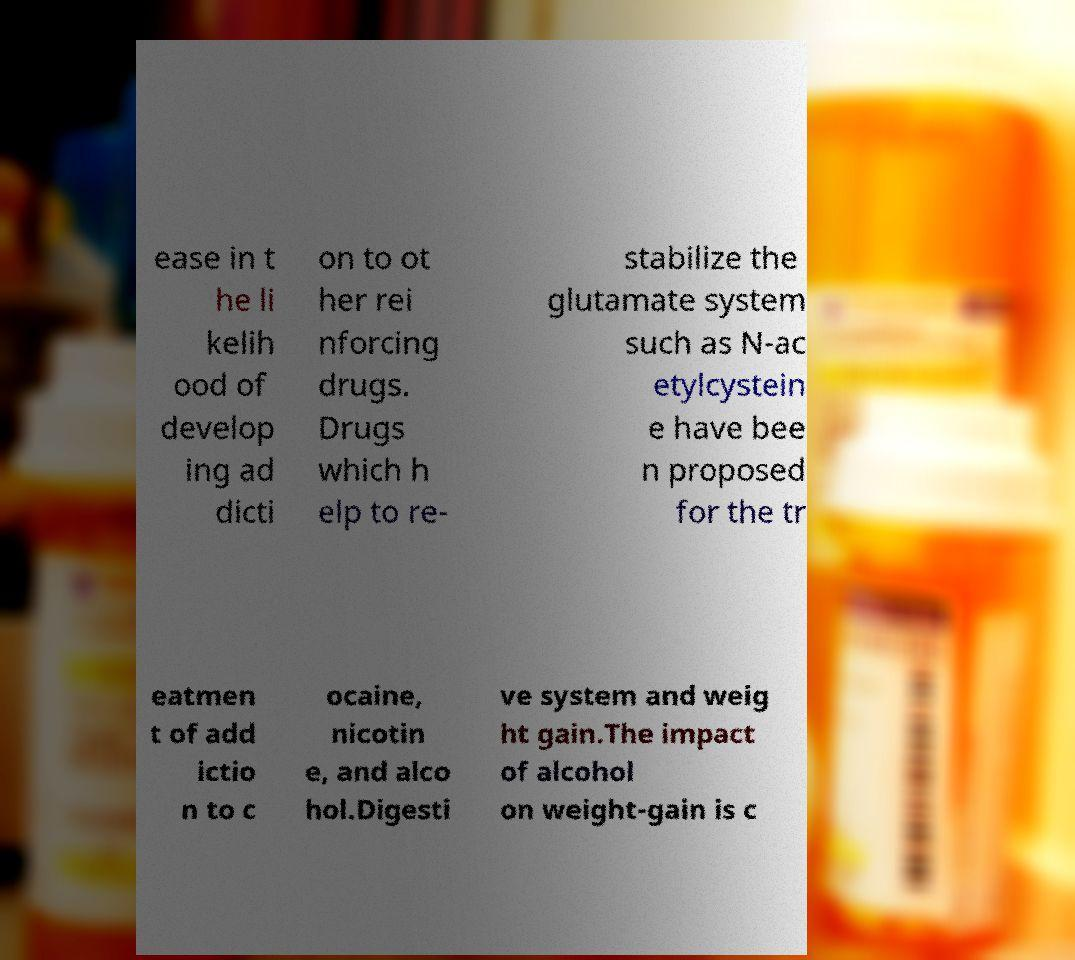Can you accurately transcribe the text from the provided image for me? ease in t he li kelih ood of develop ing ad dicti on to ot her rei nforcing drugs. Drugs which h elp to re- stabilize the glutamate system such as N-ac etylcystein e have bee n proposed for the tr eatmen t of add ictio n to c ocaine, nicotin e, and alco hol.Digesti ve system and weig ht gain.The impact of alcohol on weight-gain is c 